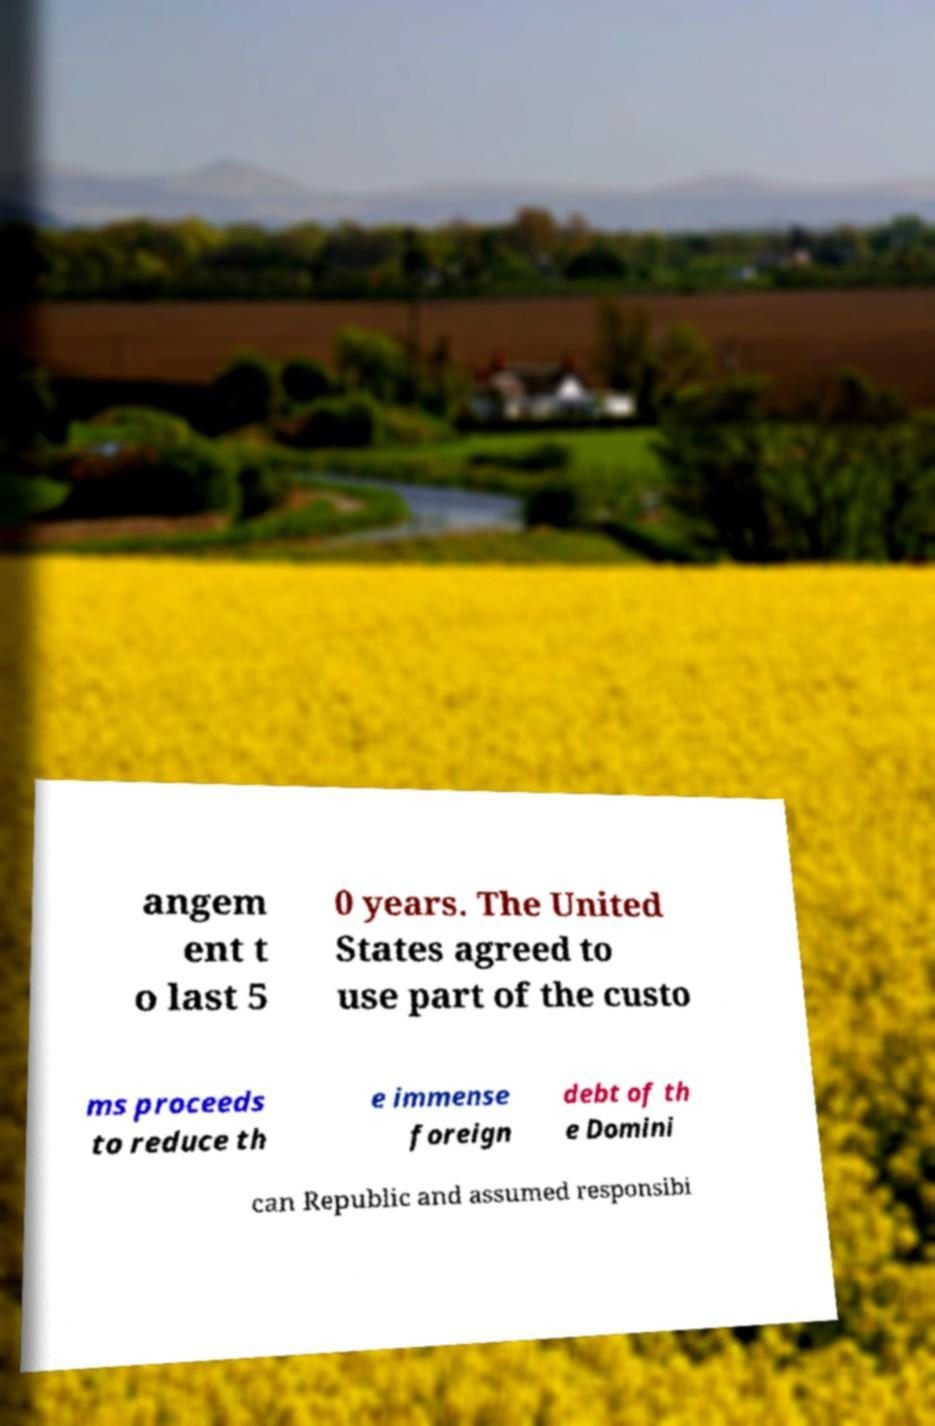For documentation purposes, I need the text within this image transcribed. Could you provide that? angem ent t o last 5 0 years. The United States agreed to use part of the custo ms proceeds to reduce th e immense foreign debt of th e Domini can Republic and assumed responsibi 